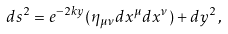<formula> <loc_0><loc_0><loc_500><loc_500>d s ^ { 2 } = e ^ { - 2 k y } ( \eta _ { \mu \nu } d x ^ { \mu } d x ^ { \nu } ) + d y ^ { 2 } \, ,</formula> 